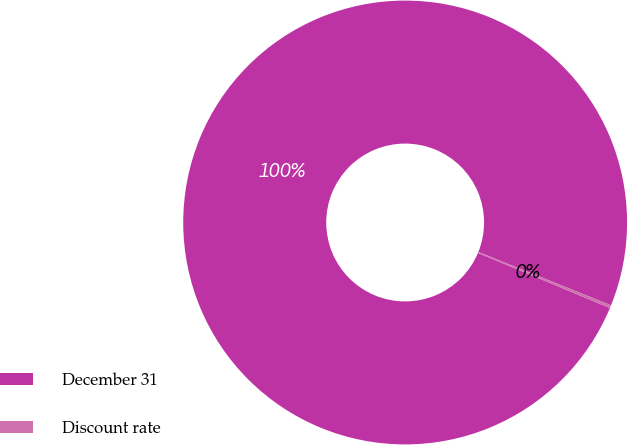<chart> <loc_0><loc_0><loc_500><loc_500><pie_chart><fcel>December 31<fcel>Discount rate<nl><fcel>99.79%<fcel>0.21%<nl></chart> 